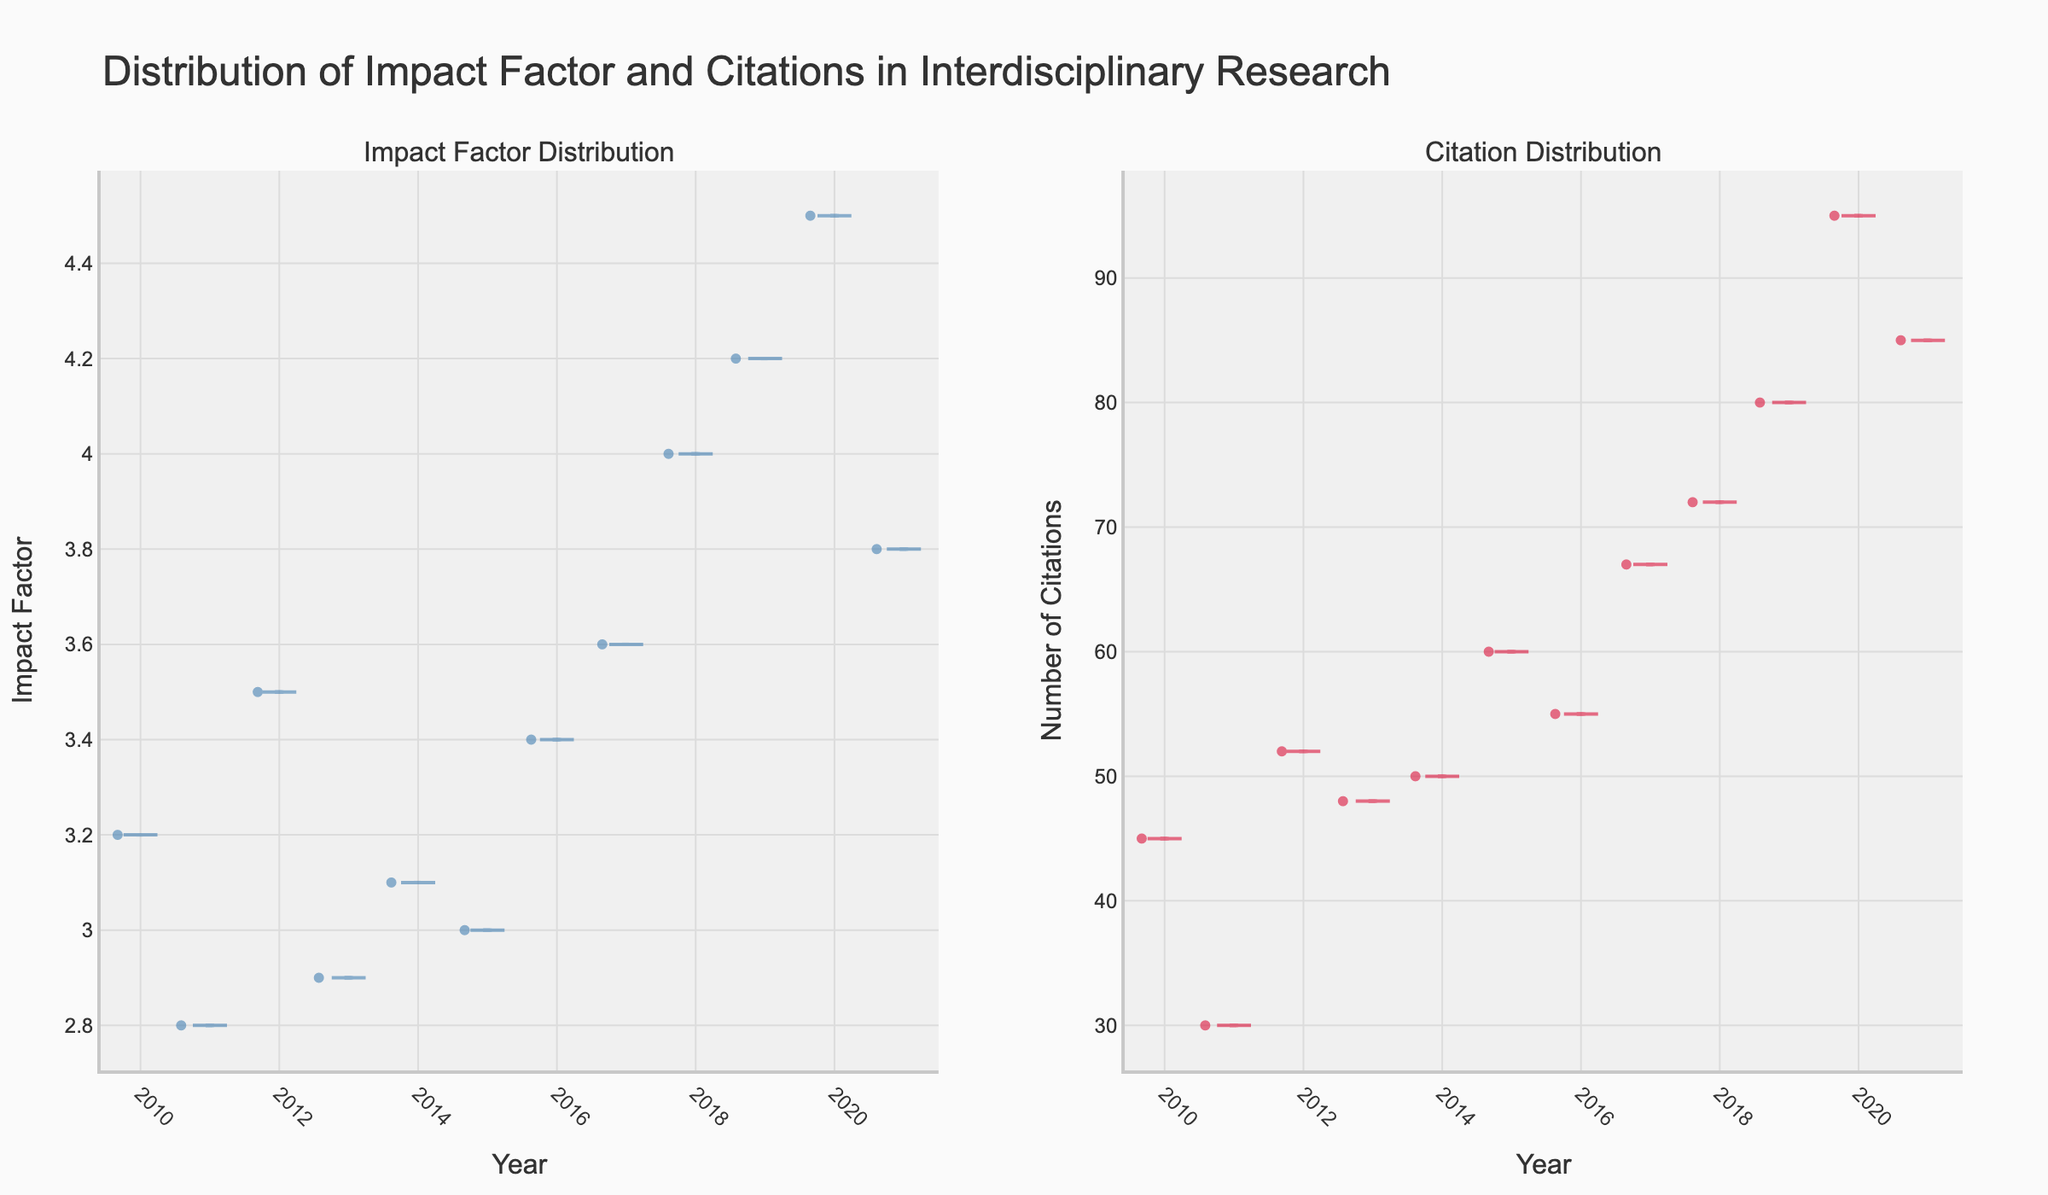What's the title of the figure? The title of the figure is displayed prominently at the top. It reads "Distribution of Impact Factor and Citations in Interdisciplinary Research".
Answer: Distribution of Impact Factor and Citations in Interdisciplinary Research What's the trend in Impact Factor distribution over the years? To determine the trend, examine the left subplot showing the distribution of Impact Factor. The distribution shows a general increase in Impact Factor over the years, indicating that newer papers tend to have higher Impact Factors.
Answer: Increase over the years How does the median Impact Factor compare between 2012 and 2019? Examine the position of the median lines in the Impact Factor violin plots for 2012 and 2019. In 2012, the median Impact Factor is approximately 3.5, while in 2019, it is around 4.2.
Answer: 2019 is higher than 2012 Which year had the highest median number of citations? Examine the median lines in the Citation Distribution violin plots. The year with the highest median line, indicating the highest median number of citations, is 2020.
Answer: 2020 How do citation numbers vary in 2020 compared to earlier years? Observe the Citation Distribution subplot. 2020 shows a larger spread and higher upper values in citations compared to earlier years, indicating higher variability and generally higher citation numbers.
Answer: Higher and more variable in 2020 What is the range of the Impact Factor in 2018? The range of the Impact Factor for 2018 can be determined by looking at the minimum and maximum points in the respective violin plot. The Impact Factor ranges from approximately 4.0 to 4.0 in 2018, indicating a narrow range.
Answer: Around 4.0 Comparing 2015 and 2017, which year had more variability in the number of citations? Look at the spread of the violin plots for citations in 2015 and 2017. The 2017 plot shows a wider spread indicating more variability in the number of citations than in 2015.
Answer: 2017 During which year do we observe the lowest median Impact Factor and what is its approximate value? Find the violin plot with the lowest median line in the Impact Factor subplot. The lowest median Impact Factor occurs in 2011 with a value of around 2.8.
Answer: 2011, approx 2.8 What is the general relationship between Impact Factor and the number of citations from 2010 to 2021? By comparing the trends across both subplots, there is a general positive relationship; as Impact Factors increase over the years, so do the number of citations, especially noticeable in later years.
Answer: Positive relationship Which metric shows more annual variability, Impact Factor or Number of Citations? Examine both subplots to compare the width and spread of the violin plots. The Number of Citations subplot shows more annual variability with wider distributions compared to Impact Factor.
Answer: Number of Citations 